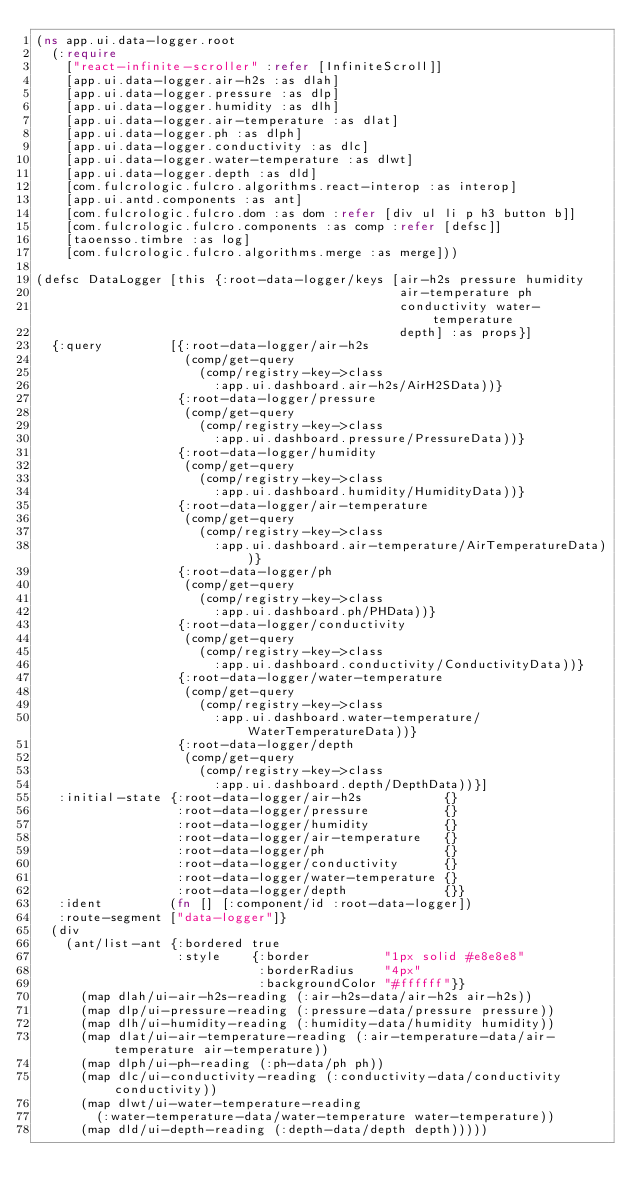Convert code to text. <code><loc_0><loc_0><loc_500><loc_500><_Clojure_>(ns app.ui.data-logger.root
  (:require
    ["react-infinite-scroller" :refer [InfiniteScroll]]
    [app.ui.data-logger.air-h2s :as dlah]
    [app.ui.data-logger.pressure :as dlp]
    [app.ui.data-logger.humidity :as dlh]
    [app.ui.data-logger.air-temperature :as dlat]
    [app.ui.data-logger.ph :as dlph]
    [app.ui.data-logger.conductivity :as dlc]
    [app.ui.data-logger.water-temperature :as dlwt]
    [app.ui.data-logger.depth :as dld]
    [com.fulcrologic.fulcro.algorithms.react-interop :as interop]
    [app.ui.antd.components :as ant]
    [com.fulcrologic.fulcro.dom :as dom :refer [div ul li p h3 button b]]
    [com.fulcrologic.fulcro.components :as comp :refer [defsc]]
    [taoensso.timbre :as log]
    [com.fulcrologic.fulcro.algorithms.merge :as merge]))

(defsc DataLogger [this {:root-data-logger/keys [air-h2s pressure humidity
                                                 air-temperature ph
                                                 conductivity water-temperature
                                                 depth] :as props}]
  {:query         [{:root-data-logger/air-h2s
                    (comp/get-query
                      (comp/registry-key->class
                        :app.ui.dashboard.air-h2s/AirH2SData))}
                   {:root-data-logger/pressure
                    (comp/get-query
                      (comp/registry-key->class
                        :app.ui.dashboard.pressure/PressureData))}
                   {:root-data-logger/humidity
                    (comp/get-query
                      (comp/registry-key->class
                        :app.ui.dashboard.humidity/HumidityData))}
                   {:root-data-logger/air-temperature
                    (comp/get-query
                      (comp/registry-key->class
                        :app.ui.dashboard.air-temperature/AirTemperatureData))}
                   {:root-data-logger/ph
                    (comp/get-query
                      (comp/registry-key->class
                        :app.ui.dashboard.ph/PHData))}
                   {:root-data-logger/conductivity
                    (comp/get-query
                      (comp/registry-key->class
                        :app.ui.dashboard.conductivity/ConductivityData))}
                   {:root-data-logger/water-temperature
                    (comp/get-query
                      (comp/registry-key->class
                        :app.ui.dashboard.water-temperature/WaterTemperatureData))}
                   {:root-data-logger/depth
                    (comp/get-query
                      (comp/registry-key->class
                        :app.ui.dashboard.depth/DepthData))}]
   :initial-state {:root-data-logger/air-h2s           {}
                   :root-data-logger/pressure          {}
                   :root-data-logger/humidity          {}
                   :root-data-logger/air-temperature   {}
                   :root-data-logger/ph                {}
                   :root-data-logger/conductivity      {}
                   :root-data-logger/water-temperature {}
                   :root-data-logger/depth             {}}
   :ident         (fn [] [:component/id :root-data-logger])
   :route-segment ["data-logger"]}
  (div
    (ant/list-ant {:bordered true
                   :style    {:border          "1px solid #e8e8e8"
                              :borderRadius    "4px"
                              :backgroundColor "#ffffff"}}
      (map dlah/ui-air-h2s-reading (:air-h2s-data/air-h2s air-h2s))
      (map dlp/ui-pressure-reading (:pressure-data/pressure pressure))
      (map dlh/ui-humidity-reading (:humidity-data/humidity humidity))
      (map dlat/ui-air-temperature-reading (:air-temperature-data/air-temperature air-temperature))
      (map dlph/ui-ph-reading (:ph-data/ph ph))
      (map dlc/ui-conductivity-reading (:conductivity-data/conductivity conductivity))
      (map dlwt/ui-water-temperature-reading
        (:water-temperature-data/water-temperature water-temperature))
      (map dld/ui-depth-reading (:depth-data/depth depth)))))
</code> 